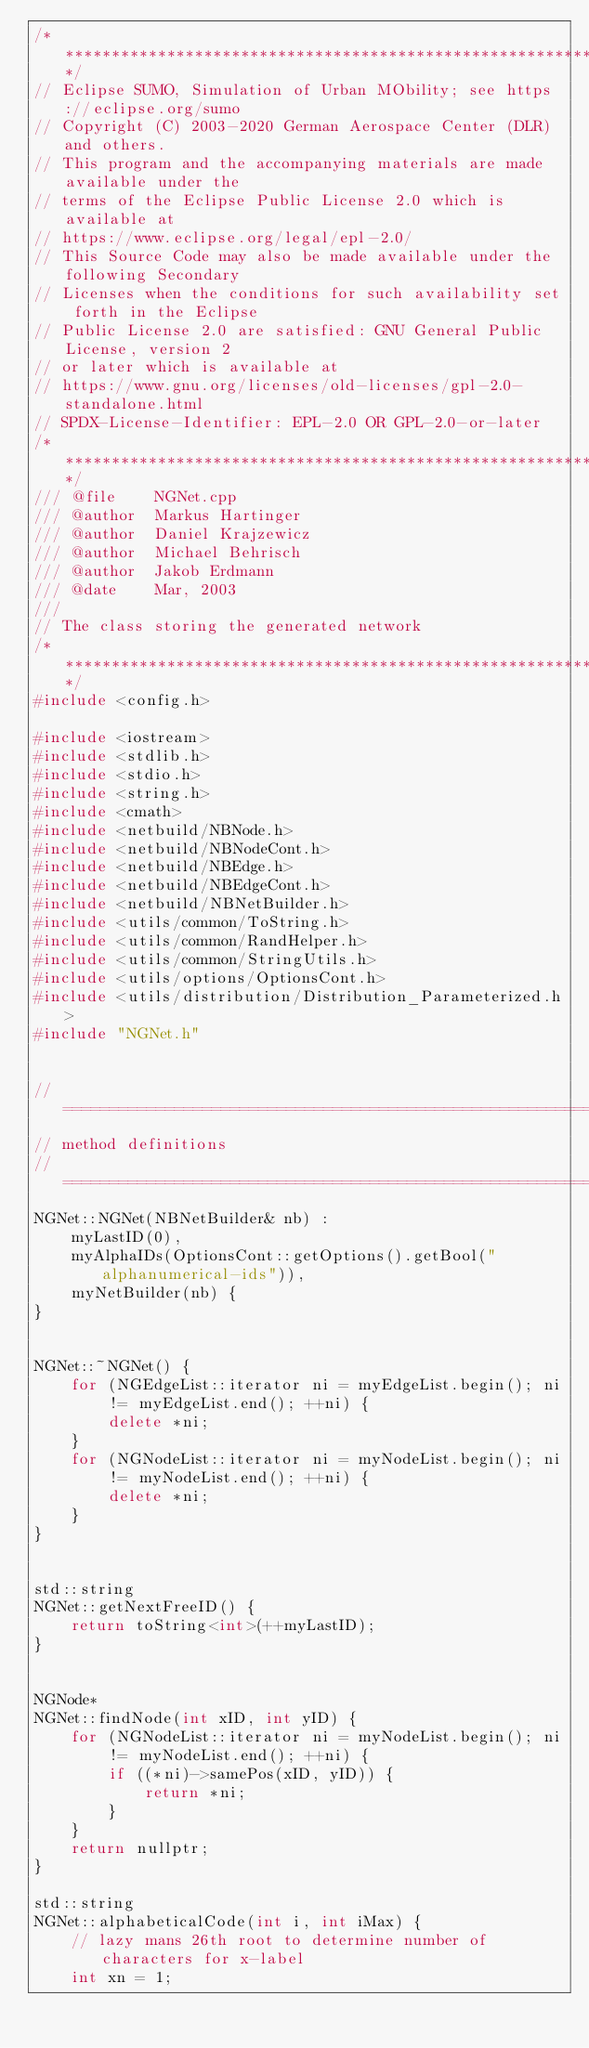Convert code to text. <code><loc_0><loc_0><loc_500><loc_500><_C++_>/****************************************************************************/
// Eclipse SUMO, Simulation of Urban MObility; see https://eclipse.org/sumo
// Copyright (C) 2003-2020 German Aerospace Center (DLR) and others.
// This program and the accompanying materials are made available under the
// terms of the Eclipse Public License 2.0 which is available at
// https://www.eclipse.org/legal/epl-2.0/
// This Source Code may also be made available under the following Secondary
// Licenses when the conditions for such availability set forth in the Eclipse
// Public License 2.0 are satisfied: GNU General Public License, version 2
// or later which is available at
// https://www.gnu.org/licenses/old-licenses/gpl-2.0-standalone.html
// SPDX-License-Identifier: EPL-2.0 OR GPL-2.0-or-later
/****************************************************************************/
/// @file    NGNet.cpp
/// @author  Markus Hartinger
/// @author  Daniel Krajzewicz
/// @author  Michael Behrisch
/// @author  Jakob Erdmann
/// @date    Mar, 2003
///
// The class storing the generated network
/****************************************************************************/
#include <config.h>

#include <iostream>
#include <stdlib.h>
#include <stdio.h>
#include <string.h>
#include <cmath>
#include <netbuild/NBNode.h>
#include <netbuild/NBNodeCont.h>
#include <netbuild/NBEdge.h>
#include <netbuild/NBEdgeCont.h>
#include <netbuild/NBNetBuilder.h>
#include <utils/common/ToString.h>
#include <utils/common/RandHelper.h>
#include <utils/common/StringUtils.h>
#include <utils/options/OptionsCont.h>
#include <utils/distribution/Distribution_Parameterized.h>
#include "NGNet.h"


// ===========================================================================
// method definitions
// ===========================================================================
NGNet::NGNet(NBNetBuilder& nb) :
    myLastID(0),
    myAlphaIDs(OptionsCont::getOptions().getBool("alphanumerical-ids")),
    myNetBuilder(nb) {
}


NGNet::~NGNet() {
    for (NGEdgeList::iterator ni = myEdgeList.begin(); ni != myEdgeList.end(); ++ni) {
        delete *ni;
    }
    for (NGNodeList::iterator ni = myNodeList.begin(); ni != myNodeList.end(); ++ni) {
        delete *ni;
    }
}


std::string
NGNet::getNextFreeID() {
    return toString<int>(++myLastID);
}


NGNode*
NGNet::findNode(int xID, int yID) {
    for (NGNodeList::iterator ni = myNodeList.begin(); ni != myNodeList.end(); ++ni) {
        if ((*ni)->samePos(xID, yID)) {
            return *ni;
        }
    }
    return nullptr;
}

std::string
NGNet::alphabeticalCode(int i, int iMax) {
    // lazy mans 26th root to determine number of characters for x-label
    int xn = 1;</code> 